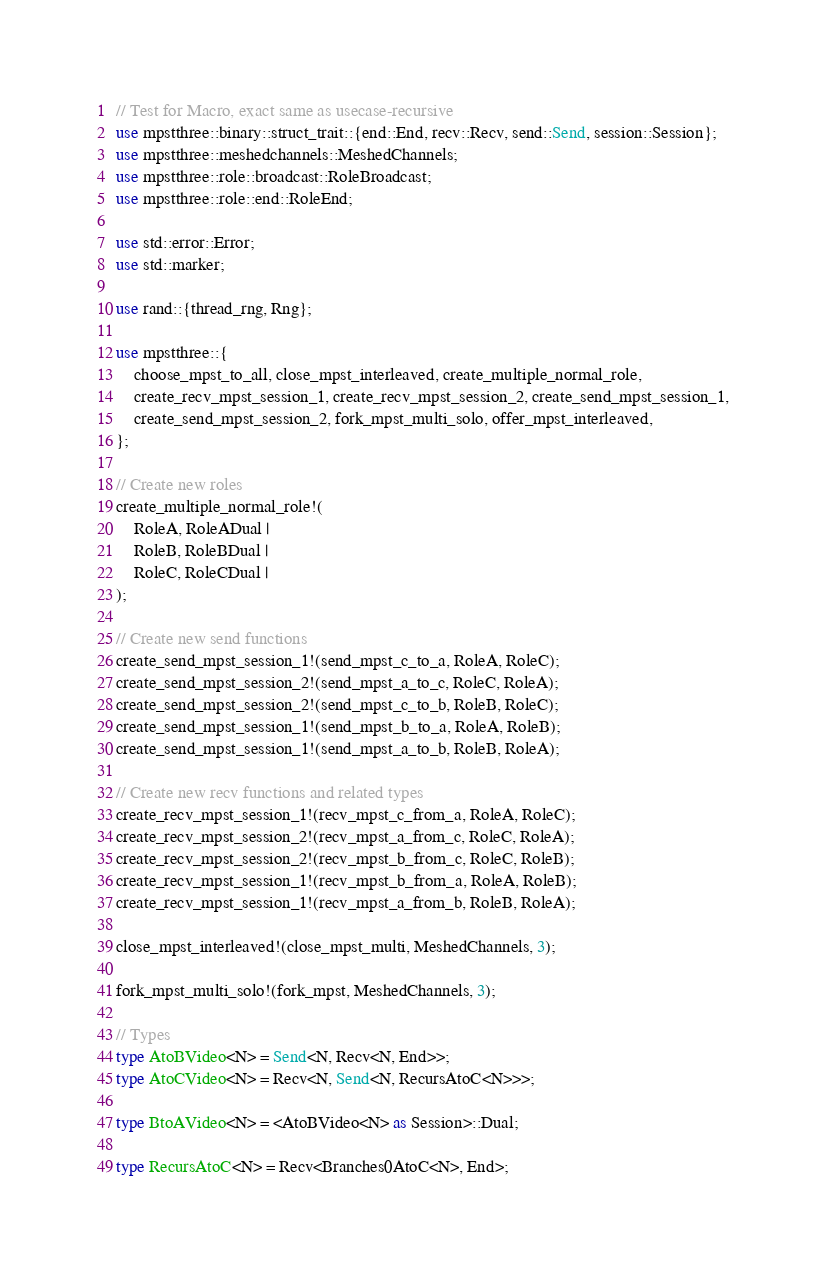<code> <loc_0><loc_0><loc_500><loc_500><_Rust_>// Test for Macro, exact same as usecase-recursive
use mpstthree::binary::struct_trait::{end::End, recv::Recv, send::Send, session::Session};
use mpstthree::meshedchannels::MeshedChannels;
use mpstthree::role::broadcast::RoleBroadcast;
use mpstthree::role::end::RoleEnd;

use std::error::Error;
use std::marker;

use rand::{thread_rng, Rng};

use mpstthree::{
    choose_mpst_to_all, close_mpst_interleaved, create_multiple_normal_role,
    create_recv_mpst_session_1, create_recv_mpst_session_2, create_send_mpst_session_1,
    create_send_mpst_session_2, fork_mpst_multi_solo, offer_mpst_interleaved,
};

// Create new roles
create_multiple_normal_role!(
    RoleA, RoleADual |
    RoleB, RoleBDual |
    RoleC, RoleCDual |
);

// Create new send functions
create_send_mpst_session_1!(send_mpst_c_to_a, RoleA, RoleC);
create_send_mpst_session_2!(send_mpst_a_to_c, RoleC, RoleA);
create_send_mpst_session_2!(send_mpst_c_to_b, RoleB, RoleC);
create_send_mpst_session_1!(send_mpst_b_to_a, RoleA, RoleB);
create_send_mpst_session_1!(send_mpst_a_to_b, RoleB, RoleA);

// Create new recv functions and related types
create_recv_mpst_session_1!(recv_mpst_c_from_a, RoleA, RoleC);
create_recv_mpst_session_2!(recv_mpst_a_from_c, RoleC, RoleA);
create_recv_mpst_session_2!(recv_mpst_b_from_c, RoleC, RoleB);
create_recv_mpst_session_1!(recv_mpst_b_from_a, RoleA, RoleB);
create_recv_mpst_session_1!(recv_mpst_a_from_b, RoleB, RoleA);

close_mpst_interleaved!(close_mpst_multi, MeshedChannels, 3);

fork_mpst_multi_solo!(fork_mpst, MeshedChannels, 3);

// Types
type AtoBVideo<N> = Send<N, Recv<N, End>>;
type AtoCVideo<N> = Recv<N, Send<N, RecursAtoC<N>>>;

type BtoAVideo<N> = <AtoBVideo<N> as Session>::Dual;

type RecursAtoC<N> = Recv<Branches0AtoC<N>, End>;</code> 